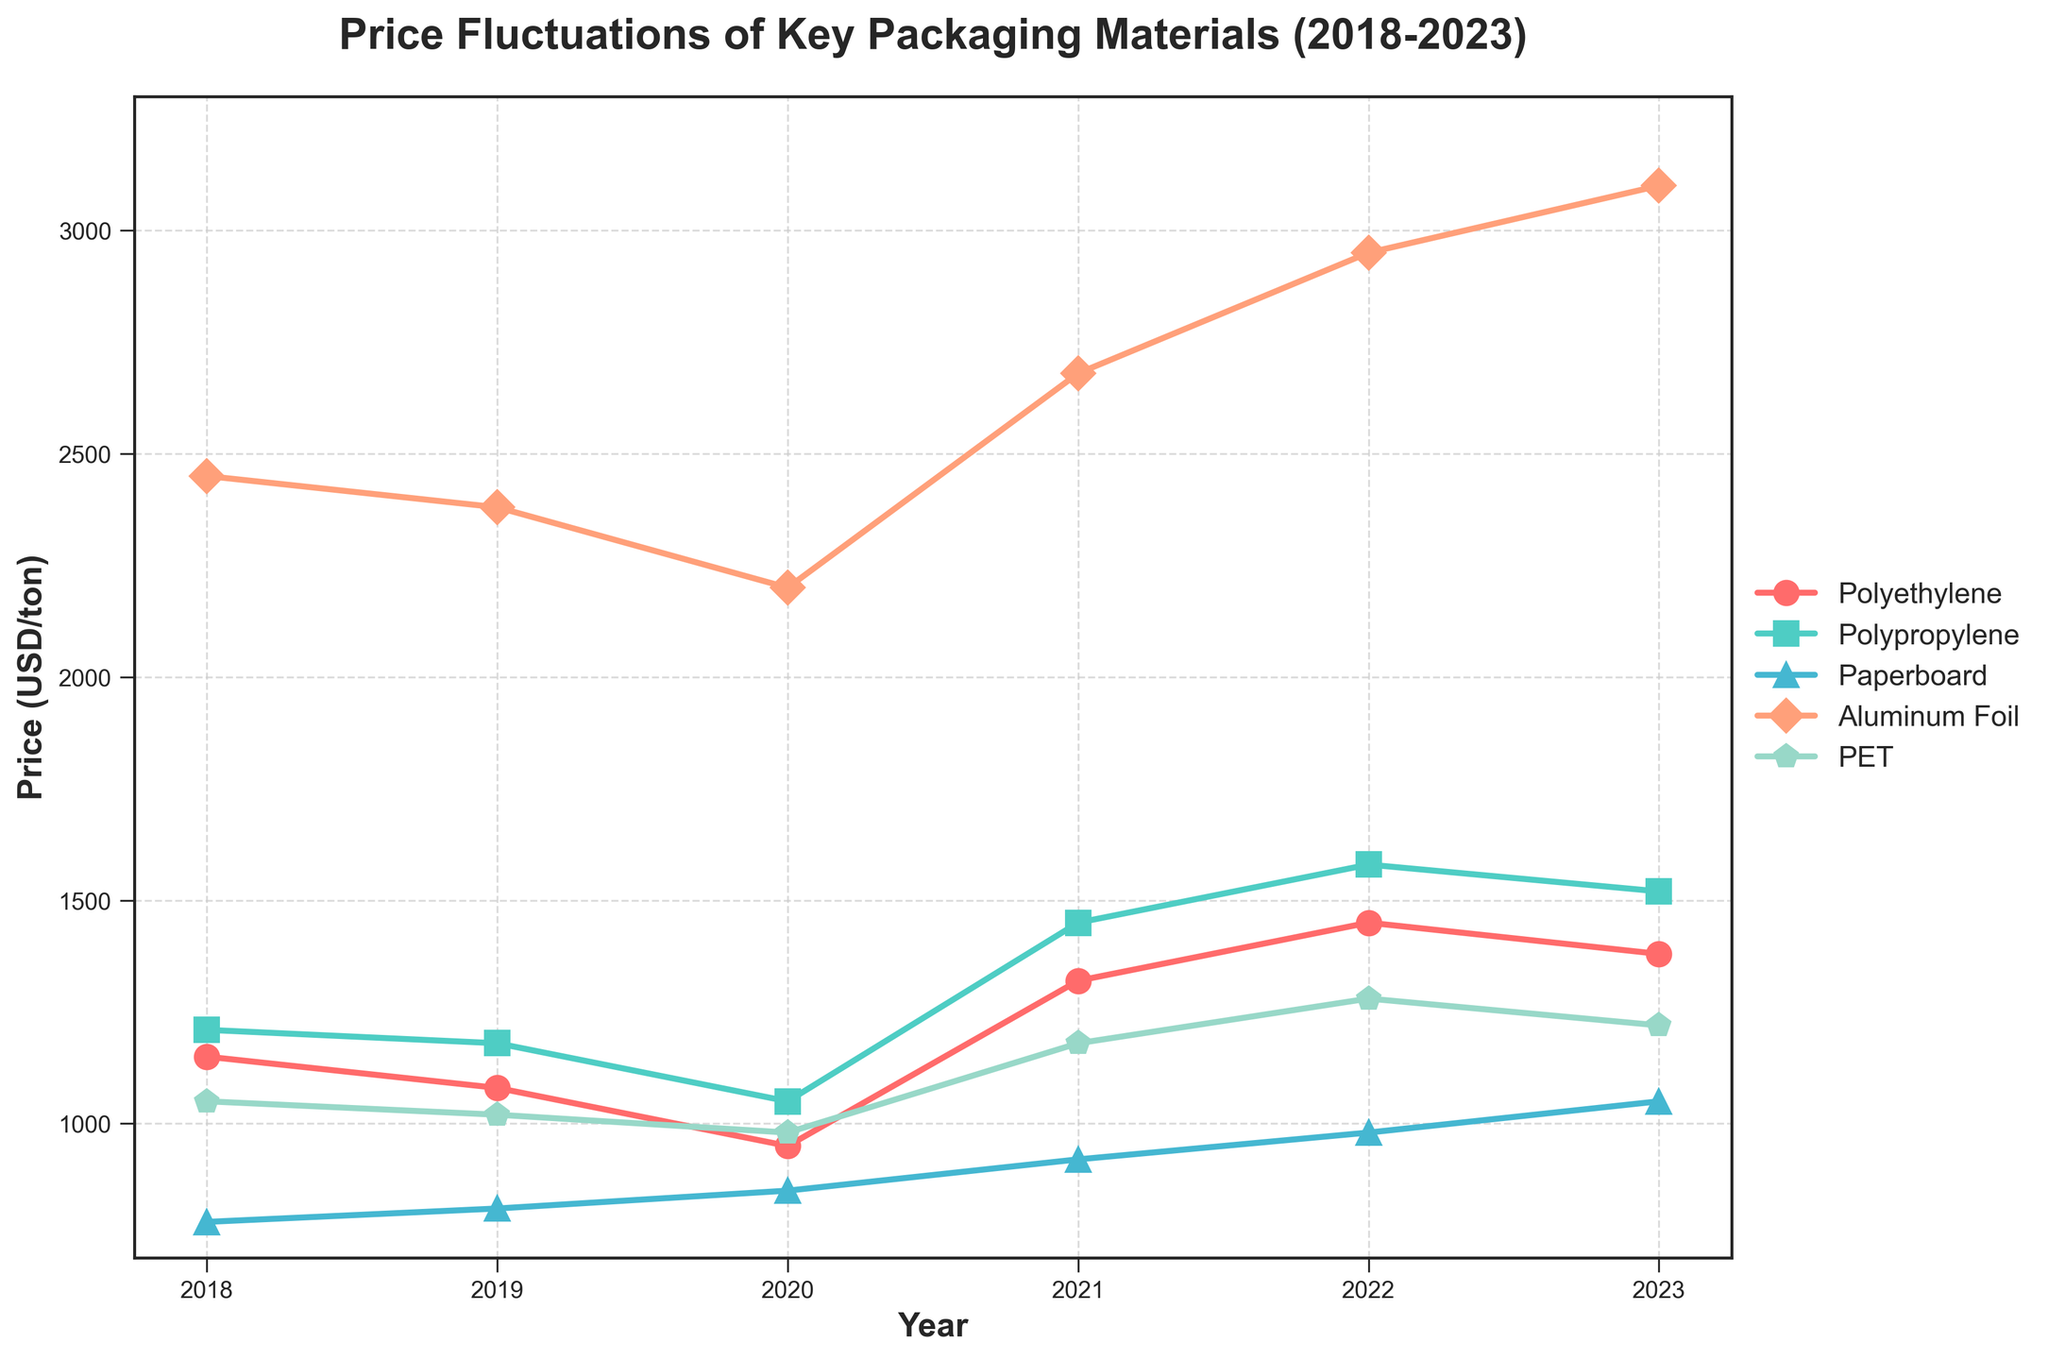What material experienced the highest price increase between 2018 and 2023? To determine the highest price increase, we calculate the price difference between 2018 and 2023 for each material. Polyethylene increased by 230 USD (1380 - 1150), Polypropylene by 310 USD (1520 - 1210), Paperboard by 270 USD (1050 - 780), Aluminum Foil by 650 USD (3100 - 2450), and PET by 170 USD (1220 - 1050). The highest increase is thus for Aluminum Foil.
Answer: Aluminum Foil Which material had the highest price in 2023? To find the material with the highest price in 2023, we look at the prices in 2023: Polyethylene is 1380 USD, Polypropylene is 1520 USD, Paperboard is 1050 USD, Aluminum Foil is 3100 USD, and PET is 1220 USD. The highest price is for Aluminum Foil.
Answer: Aluminum Foil In which year did PET have the lowest price? To find the year with the lowest price for PET, we compare PET prices across the years: 1050 (2018), 1020 (2019), 980 (2020), 1180 (2021), 1280 (2022), 1220 (2023). The lowest price is in 2020.
Answer: 2020 Between which years did Polyethylene experience the largest price increase? To find the largest price increase for Polyethylene, we calculate the year-to-year differences: 1150 to 1080 (decrease by 70), 1080 to 950 (decrease by 130), 950 to 1320 (increase by 370), 1320 to 1450 (increase by 130), 1450 to 1380 (decrease by 70). The largest increase is between 2020 and 2021.
Answer: 2020 to 2021 What is the average price of Paperboard over the five years? To calculate the average price, sum up the yearly prices and divide by the number of years: (780 + 810 + 850 + 920 + 980 + 1050) / 6 = 5390 / 6 = 898.33 USD/ton.
Answer: 898.33 USD/ton Which material had a consistent price increase every year? To find a material with consistent price increases, we need to check the year-to-year changes: Polyethylene (decrease in initial years), Polypropylene (decrease in initial years), Paperboard (increase every year), Aluminum Foil (consistent decrease and increase), and PET (decrease initially). Only Paperboard had consistent increases.
Answer: Paperboard How does the price of Aluminum Foil in 2021 compare to its price in 2023? To compare the prices, we look at the values for Aluminum Foil: 2680 USD in 2021 and 3100 USD in 2023. The price in 2023 is higher by 3100 - 2680 = 420 USD.
Answer: Higher by 420 USD What was the difference in the price of Polypropylene between 2018 and 2020? To find the difference, subtract the price in 2020 from the price in 2018 for Polypropylene: 1210 - 1050 = 160 USD.
Answer: 160 USD Which material showed a price decrease from 2022 to 2023? To identify the material with a price decrease from 2022 to 2023, compare prices for each material: Polyethylene (1450 to 1380: decrease), Polypropylene (1580 to 1520: decrease), Paperboard (980 to 1050: increase), Aluminum Foil (2950 to 3100: increase), PET (1280 to 1220: decrease). Polyethylene, Polypropylene, and PET showed decreases.
Answer: Polyethylene, Polypropylene, PET 